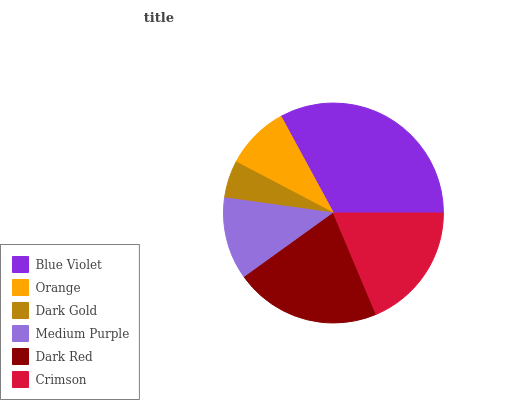Is Dark Gold the minimum?
Answer yes or no. Yes. Is Blue Violet the maximum?
Answer yes or no. Yes. Is Orange the minimum?
Answer yes or no. No. Is Orange the maximum?
Answer yes or no. No. Is Blue Violet greater than Orange?
Answer yes or no. Yes. Is Orange less than Blue Violet?
Answer yes or no. Yes. Is Orange greater than Blue Violet?
Answer yes or no. No. Is Blue Violet less than Orange?
Answer yes or no. No. Is Crimson the high median?
Answer yes or no. Yes. Is Medium Purple the low median?
Answer yes or no. Yes. Is Blue Violet the high median?
Answer yes or no. No. Is Dark Gold the low median?
Answer yes or no. No. 